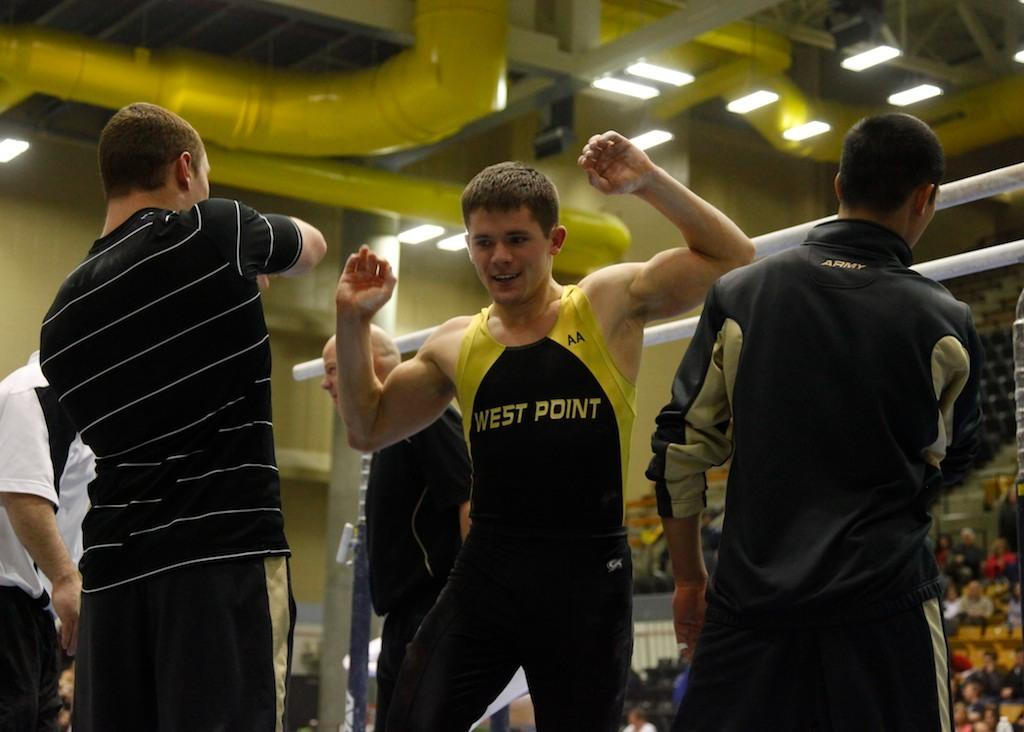<image>
Give a short and clear explanation of the subsequent image. A group of male athletes from West Point in the gymnastics arena 